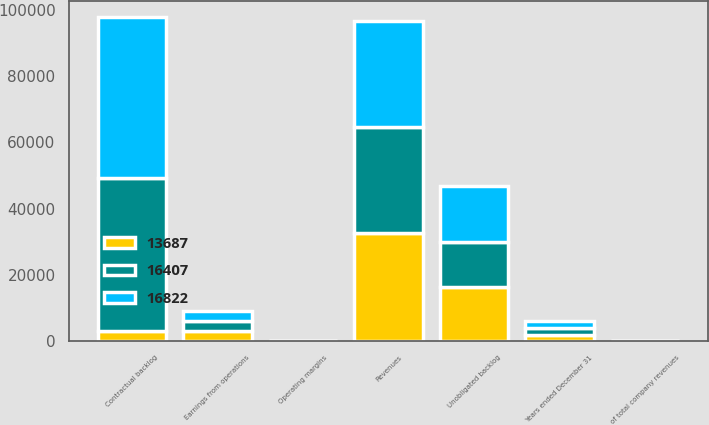<chart> <loc_0><loc_0><loc_500><loc_500><stacked_bar_chart><ecel><fcel>Years ended December 31<fcel>Revenues<fcel>of total company revenues<fcel>Earnings from operations<fcel>Operating margins<fcel>Contractual backlog<fcel>Unobligated backlog<nl><fcel>13687<fcel>2012<fcel>32607<fcel>40<fcel>3068<fcel>9.4<fcel>2971.5<fcel>16407<nl><fcel>16407<fcel>2011<fcel>31976<fcel>47<fcel>3158<fcel>9.9<fcel>46354<fcel>13687<nl><fcel>16822<fcel>2010<fcel>31943<fcel>50<fcel>2875<fcel>9<fcel>48364<fcel>16822<nl></chart> 